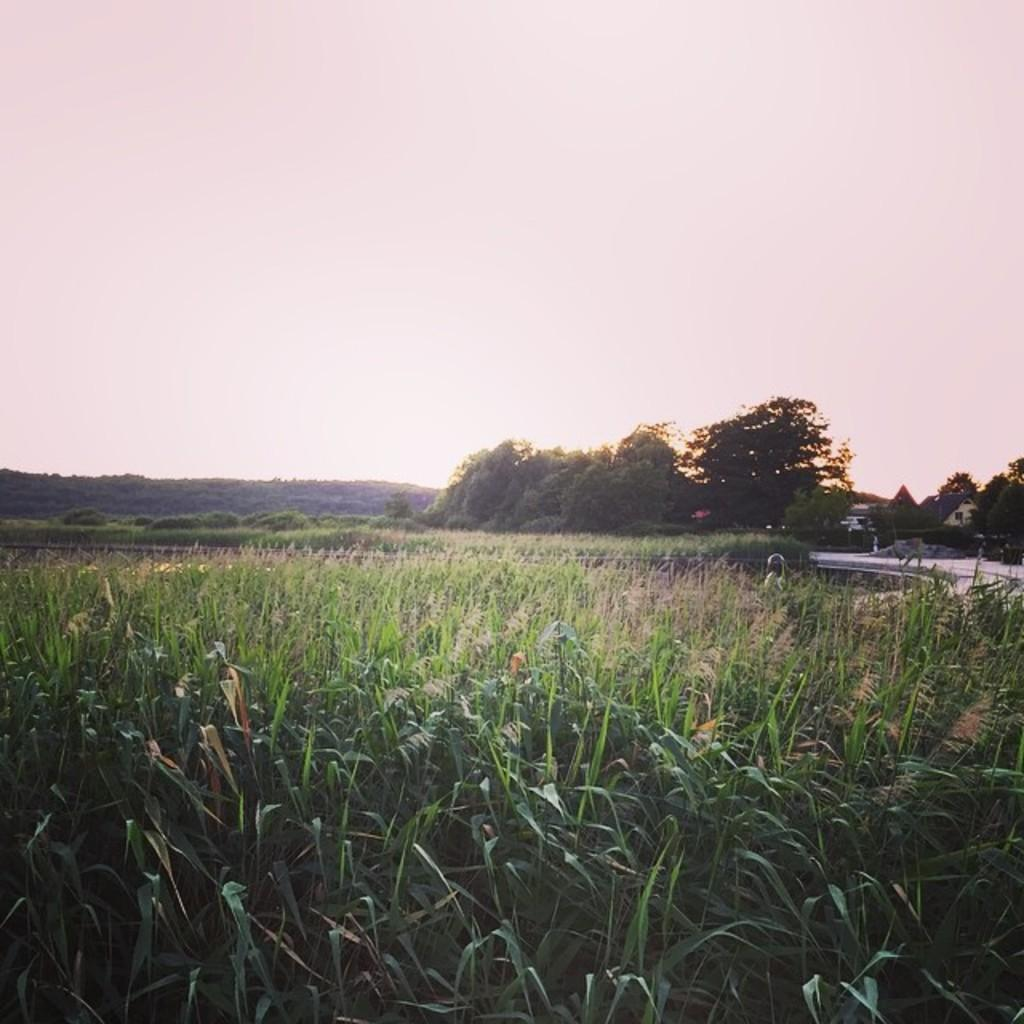What type of view is shown in the image? The image is an outside view. What can be seen at the bottom of the image? There are many plants at the bottom of the image. What is located on the right side of the image? There is a road and houses on the right side of the image, as well as trees. What is visible at the top of the image? The sky is visible at the top of the image. What verse is being recited by the toe in the image? There is no toe or verse present in the image. 